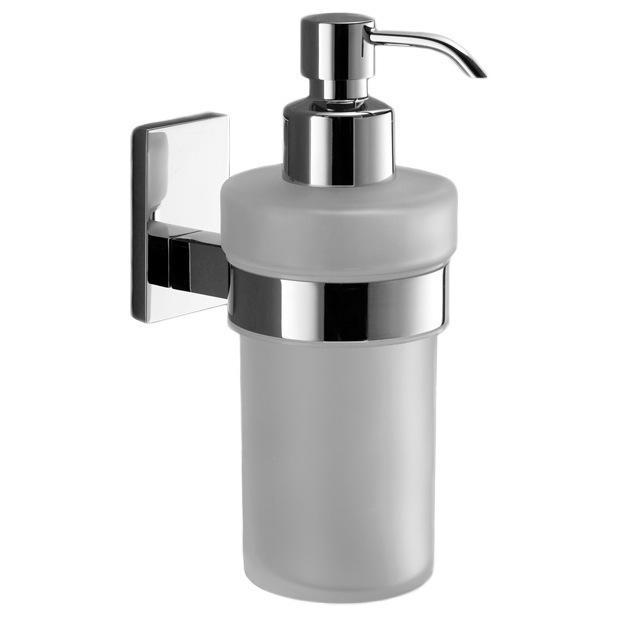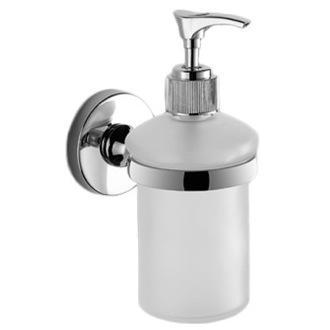The first image is the image on the left, the second image is the image on the right. Analyze the images presented: Is the assertion "One image shows a dispenser with a right-turned nozzle that mounts on the wall with a chrome band around it, and the other image shows a free-standing pump-top dispenser with a chrome top." valid? Answer yes or no. No. 